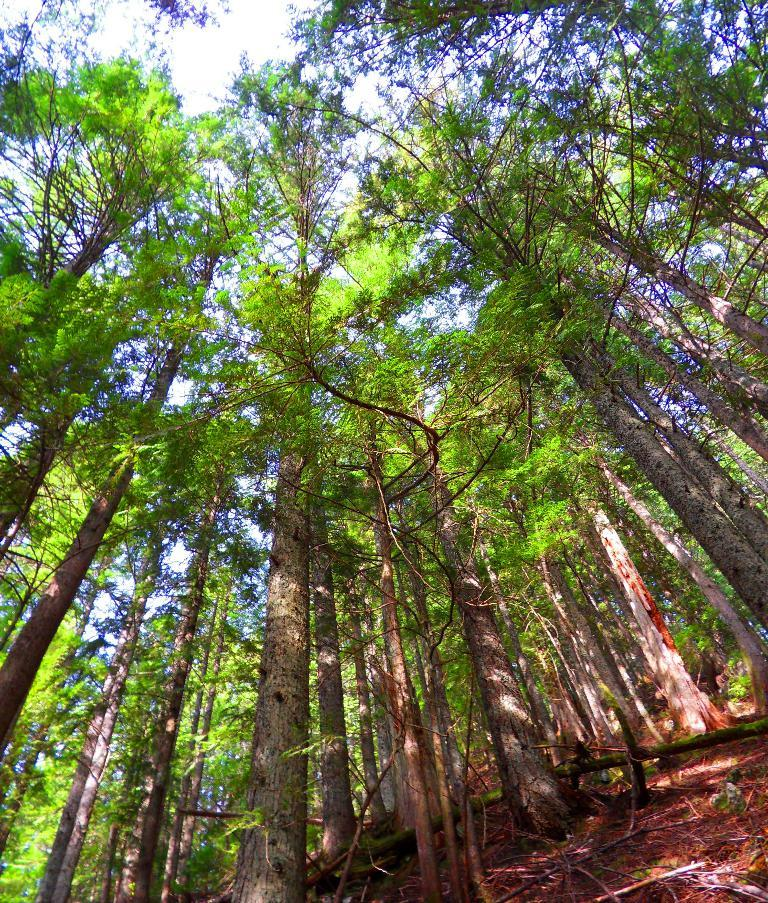What type of surface is visible in the image? There is ground visible in the image. What can be found on the ground in the image? There are trees on the ground in the image. What is visible above the ground in the image? The sky is visible at the top of the image. What type of root can be seen growing from the trees in the image? There is no root visible in the image; only the trees themselves are shown. Is there any indication of a birthday celebration in the image? There is no indication of a birthday celebration in the image. 